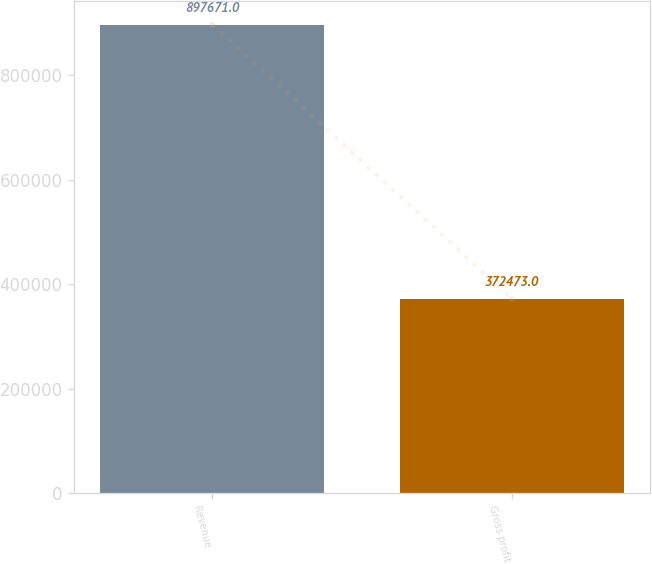Convert chart to OTSL. <chart><loc_0><loc_0><loc_500><loc_500><bar_chart><fcel>Revenue<fcel>Gross profit<nl><fcel>897671<fcel>372473<nl></chart> 